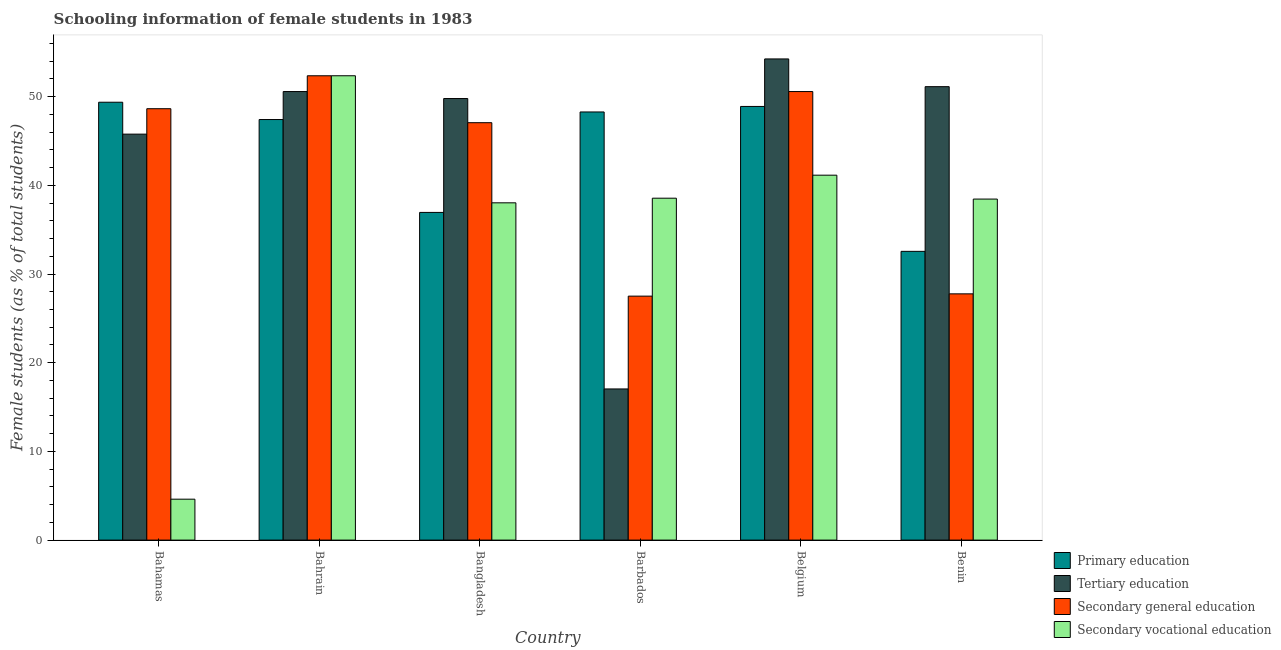How many different coloured bars are there?
Give a very brief answer. 4. Are the number of bars on each tick of the X-axis equal?
Ensure brevity in your answer.  Yes. What is the label of the 6th group of bars from the left?
Keep it short and to the point. Benin. What is the percentage of female students in secondary vocational education in Bahrain?
Offer a terse response. 52.36. Across all countries, what is the maximum percentage of female students in secondary education?
Offer a very short reply. 52.36. Across all countries, what is the minimum percentage of female students in secondary education?
Your response must be concise. 27.51. In which country was the percentage of female students in primary education maximum?
Offer a very short reply. Bahamas. In which country was the percentage of female students in tertiary education minimum?
Your response must be concise. Barbados. What is the total percentage of female students in tertiary education in the graph?
Provide a short and direct response. 268.57. What is the difference between the percentage of female students in primary education in Bahrain and that in Benin?
Give a very brief answer. 14.86. What is the difference between the percentage of female students in secondary education in Bahrain and the percentage of female students in secondary vocational education in Belgium?
Keep it short and to the point. 11.21. What is the average percentage of female students in primary education per country?
Give a very brief answer. 43.91. What is the difference between the percentage of female students in primary education and percentage of female students in secondary vocational education in Benin?
Your answer should be compact. -5.89. In how many countries, is the percentage of female students in secondary education greater than 4 %?
Provide a short and direct response. 6. What is the ratio of the percentage of female students in secondary education in Bahrain to that in Barbados?
Offer a terse response. 1.9. What is the difference between the highest and the second highest percentage of female students in tertiary education?
Give a very brief answer. 3.13. What is the difference between the highest and the lowest percentage of female students in secondary vocational education?
Give a very brief answer. 47.74. What does the 2nd bar from the left in Bahamas represents?
Give a very brief answer. Tertiary education. What does the 3rd bar from the right in Barbados represents?
Your answer should be compact. Tertiary education. How many countries are there in the graph?
Your answer should be compact. 6. Are the values on the major ticks of Y-axis written in scientific E-notation?
Your answer should be very brief. No. Does the graph contain any zero values?
Your answer should be compact. No. Does the graph contain grids?
Ensure brevity in your answer.  No. How are the legend labels stacked?
Your answer should be compact. Vertical. What is the title of the graph?
Offer a terse response. Schooling information of female students in 1983. What is the label or title of the X-axis?
Your answer should be very brief. Country. What is the label or title of the Y-axis?
Your answer should be very brief. Female students (as % of total students). What is the Female students (as % of total students) of Primary education in Bahamas?
Your answer should be very brief. 49.37. What is the Female students (as % of total students) of Tertiary education in Bahamas?
Offer a terse response. 45.78. What is the Female students (as % of total students) of Secondary general education in Bahamas?
Offer a very short reply. 48.64. What is the Female students (as % of total students) of Secondary vocational education in Bahamas?
Keep it short and to the point. 4.61. What is the Female students (as % of total students) of Primary education in Bahrain?
Ensure brevity in your answer.  47.42. What is the Female students (as % of total students) in Tertiary education in Bahrain?
Keep it short and to the point. 50.58. What is the Female students (as % of total students) of Secondary general education in Bahrain?
Your answer should be compact. 52.36. What is the Female students (as % of total students) of Secondary vocational education in Bahrain?
Ensure brevity in your answer.  52.36. What is the Female students (as % of total students) in Primary education in Bangladesh?
Make the answer very short. 36.95. What is the Female students (as % of total students) in Tertiary education in Bangladesh?
Your response must be concise. 49.79. What is the Female students (as % of total students) of Secondary general education in Bangladesh?
Give a very brief answer. 47.06. What is the Female students (as % of total students) in Secondary vocational education in Bangladesh?
Make the answer very short. 38.03. What is the Female students (as % of total students) of Primary education in Barbados?
Provide a short and direct response. 48.27. What is the Female students (as % of total students) in Tertiary education in Barbados?
Provide a succinct answer. 17.04. What is the Female students (as % of total students) of Secondary general education in Barbados?
Make the answer very short. 27.51. What is the Female students (as % of total students) of Secondary vocational education in Barbados?
Your answer should be compact. 38.55. What is the Female students (as % of total students) in Primary education in Belgium?
Ensure brevity in your answer.  48.9. What is the Female students (as % of total students) in Tertiary education in Belgium?
Make the answer very short. 54.25. What is the Female students (as % of total students) of Secondary general education in Belgium?
Give a very brief answer. 50.58. What is the Female students (as % of total students) in Secondary vocational education in Belgium?
Your response must be concise. 41.15. What is the Female students (as % of total students) of Primary education in Benin?
Your response must be concise. 32.56. What is the Female students (as % of total students) of Tertiary education in Benin?
Your response must be concise. 51.13. What is the Female students (as % of total students) in Secondary general education in Benin?
Your answer should be very brief. 27.77. What is the Female students (as % of total students) in Secondary vocational education in Benin?
Your answer should be very brief. 38.45. Across all countries, what is the maximum Female students (as % of total students) in Primary education?
Keep it short and to the point. 49.37. Across all countries, what is the maximum Female students (as % of total students) of Tertiary education?
Ensure brevity in your answer.  54.25. Across all countries, what is the maximum Female students (as % of total students) of Secondary general education?
Make the answer very short. 52.36. Across all countries, what is the maximum Female students (as % of total students) of Secondary vocational education?
Your answer should be very brief. 52.36. Across all countries, what is the minimum Female students (as % of total students) of Primary education?
Offer a terse response. 32.56. Across all countries, what is the minimum Female students (as % of total students) in Tertiary education?
Provide a succinct answer. 17.04. Across all countries, what is the minimum Female students (as % of total students) of Secondary general education?
Give a very brief answer. 27.51. Across all countries, what is the minimum Female students (as % of total students) in Secondary vocational education?
Ensure brevity in your answer.  4.61. What is the total Female students (as % of total students) of Primary education in the graph?
Your answer should be compact. 263.47. What is the total Female students (as % of total students) of Tertiary education in the graph?
Make the answer very short. 268.57. What is the total Female students (as % of total students) in Secondary general education in the graph?
Give a very brief answer. 253.91. What is the total Female students (as % of total students) of Secondary vocational education in the graph?
Keep it short and to the point. 213.15. What is the difference between the Female students (as % of total students) of Primary education in Bahamas and that in Bahrain?
Your response must be concise. 1.95. What is the difference between the Female students (as % of total students) of Tertiary education in Bahamas and that in Bahrain?
Make the answer very short. -4.8. What is the difference between the Female students (as % of total students) in Secondary general education in Bahamas and that in Bahrain?
Ensure brevity in your answer.  -3.71. What is the difference between the Female students (as % of total students) in Secondary vocational education in Bahamas and that in Bahrain?
Ensure brevity in your answer.  -47.74. What is the difference between the Female students (as % of total students) of Primary education in Bahamas and that in Bangladesh?
Your answer should be compact. 12.42. What is the difference between the Female students (as % of total students) of Tertiary education in Bahamas and that in Bangladesh?
Ensure brevity in your answer.  -4.01. What is the difference between the Female students (as % of total students) of Secondary general education in Bahamas and that in Bangladesh?
Keep it short and to the point. 1.58. What is the difference between the Female students (as % of total students) in Secondary vocational education in Bahamas and that in Bangladesh?
Offer a terse response. -33.42. What is the difference between the Female students (as % of total students) in Primary education in Bahamas and that in Barbados?
Give a very brief answer. 1.1. What is the difference between the Female students (as % of total students) in Tertiary education in Bahamas and that in Barbados?
Ensure brevity in your answer.  28.73. What is the difference between the Female students (as % of total students) of Secondary general education in Bahamas and that in Barbados?
Your response must be concise. 21.13. What is the difference between the Female students (as % of total students) of Secondary vocational education in Bahamas and that in Barbados?
Provide a short and direct response. -33.94. What is the difference between the Female students (as % of total students) of Primary education in Bahamas and that in Belgium?
Offer a terse response. 0.47. What is the difference between the Female students (as % of total students) in Tertiary education in Bahamas and that in Belgium?
Provide a succinct answer. -8.48. What is the difference between the Female students (as % of total students) in Secondary general education in Bahamas and that in Belgium?
Give a very brief answer. -1.93. What is the difference between the Female students (as % of total students) of Secondary vocational education in Bahamas and that in Belgium?
Ensure brevity in your answer.  -36.53. What is the difference between the Female students (as % of total students) in Primary education in Bahamas and that in Benin?
Your answer should be very brief. 16.82. What is the difference between the Female students (as % of total students) in Tertiary education in Bahamas and that in Benin?
Ensure brevity in your answer.  -5.35. What is the difference between the Female students (as % of total students) in Secondary general education in Bahamas and that in Benin?
Give a very brief answer. 20.88. What is the difference between the Female students (as % of total students) in Secondary vocational education in Bahamas and that in Benin?
Your answer should be compact. -33.84. What is the difference between the Female students (as % of total students) in Primary education in Bahrain and that in Bangladesh?
Your response must be concise. 10.47. What is the difference between the Female students (as % of total students) of Tertiary education in Bahrain and that in Bangladesh?
Your response must be concise. 0.79. What is the difference between the Female students (as % of total students) in Secondary general education in Bahrain and that in Bangladesh?
Provide a succinct answer. 5.29. What is the difference between the Female students (as % of total students) in Secondary vocational education in Bahrain and that in Bangladesh?
Your answer should be very brief. 14.33. What is the difference between the Female students (as % of total students) of Primary education in Bahrain and that in Barbados?
Keep it short and to the point. -0.85. What is the difference between the Female students (as % of total students) of Tertiary education in Bahrain and that in Barbados?
Ensure brevity in your answer.  33.53. What is the difference between the Female students (as % of total students) in Secondary general education in Bahrain and that in Barbados?
Offer a terse response. 24.85. What is the difference between the Female students (as % of total students) of Secondary vocational education in Bahrain and that in Barbados?
Offer a terse response. 13.81. What is the difference between the Female students (as % of total students) in Primary education in Bahrain and that in Belgium?
Your answer should be very brief. -1.48. What is the difference between the Female students (as % of total students) of Tertiary education in Bahrain and that in Belgium?
Provide a short and direct response. -3.68. What is the difference between the Female students (as % of total students) in Secondary general education in Bahrain and that in Belgium?
Ensure brevity in your answer.  1.78. What is the difference between the Female students (as % of total students) in Secondary vocational education in Bahrain and that in Belgium?
Offer a terse response. 11.21. What is the difference between the Female students (as % of total students) of Primary education in Bahrain and that in Benin?
Offer a terse response. 14.86. What is the difference between the Female students (as % of total students) in Tertiary education in Bahrain and that in Benin?
Ensure brevity in your answer.  -0.55. What is the difference between the Female students (as % of total students) of Secondary general education in Bahrain and that in Benin?
Ensure brevity in your answer.  24.59. What is the difference between the Female students (as % of total students) of Secondary vocational education in Bahrain and that in Benin?
Give a very brief answer. 13.9. What is the difference between the Female students (as % of total students) in Primary education in Bangladesh and that in Barbados?
Offer a very short reply. -11.33. What is the difference between the Female students (as % of total students) in Tertiary education in Bangladesh and that in Barbados?
Make the answer very short. 32.74. What is the difference between the Female students (as % of total students) of Secondary general education in Bangladesh and that in Barbados?
Keep it short and to the point. 19.56. What is the difference between the Female students (as % of total students) of Secondary vocational education in Bangladesh and that in Barbados?
Make the answer very short. -0.52. What is the difference between the Female students (as % of total students) in Primary education in Bangladesh and that in Belgium?
Your answer should be compact. -11.95. What is the difference between the Female students (as % of total students) of Tertiary education in Bangladesh and that in Belgium?
Ensure brevity in your answer.  -4.47. What is the difference between the Female students (as % of total students) of Secondary general education in Bangladesh and that in Belgium?
Your answer should be very brief. -3.51. What is the difference between the Female students (as % of total students) of Secondary vocational education in Bangladesh and that in Belgium?
Give a very brief answer. -3.12. What is the difference between the Female students (as % of total students) in Primary education in Bangladesh and that in Benin?
Your answer should be very brief. 4.39. What is the difference between the Female students (as % of total students) of Tertiary education in Bangladesh and that in Benin?
Make the answer very short. -1.34. What is the difference between the Female students (as % of total students) of Secondary general education in Bangladesh and that in Benin?
Give a very brief answer. 19.3. What is the difference between the Female students (as % of total students) in Secondary vocational education in Bangladesh and that in Benin?
Ensure brevity in your answer.  -0.42. What is the difference between the Female students (as % of total students) of Primary education in Barbados and that in Belgium?
Ensure brevity in your answer.  -0.62. What is the difference between the Female students (as % of total students) in Tertiary education in Barbados and that in Belgium?
Your response must be concise. -37.21. What is the difference between the Female students (as % of total students) of Secondary general education in Barbados and that in Belgium?
Make the answer very short. -23.07. What is the difference between the Female students (as % of total students) of Secondary vocational education in Barbados and that in Belgium?
Your answer should be very brief. -2.6. What is the difference between the Female students (as % of total students) in Primary education in Barbados and that in Benin?
Your answer should be compact. 15.72. What is the difference between the Female students (as % of total students) in Tertiary education in Barbados and that in Benin?
Make the answer very short. -34.08. What is the difference between the Female students (as % of total students) in Secondary general education in Barbados and that in Benin?
Ensure brevity in your answer.  -0.26. What is the difference between the Female students (as % of total students) in Secondary vocational education in Barbados and that in Benin?
Keep it short and to the point. 0.1. What is the difference between the Female students (as % of total students) in Primary education in Belgium and that in Benin?
Your response must be concise. 16.34. What is the difference between the Female students (as % of total students) of Tertiary education in Belgium and that in Benin?
Ensure brevity in your answer.  3.13. What is the difference between the Female students (as % of total students) of Secondary general education in Belgium and that in Benin?
Keep it short and to the point. 22.81. What is the difference between the Female students (as % of total students) in Secondary vocational education in Belgium and that in Benin?
Give a very brief answer. 2.69. What is the difference between the Female students (as % of total students) in Primary education in Bahamas and the Female students (as % of total students) in Tertiary education in Bahrain?
Make the answer very short. -1.2. What is the difference between the Female students (as % of total students) in Primary education in Bahamas and the Female students (as % of total students) in Secondary general education in Bahrain?
Your response must be concise. -2.98. What is the difference between the Female students (as % of total students) of Primary education in Bahamas and the Female students (as % of total students) of Secondary vocational education in Bahrain?
Your answer should be compact. -2.98. What is the difference between the Female students (as % of total students) of Tertiary education in Bahamas and the Female students (as % of total students) of Secondary general education in Bahrain?
Ensure brevity in your answer.  -6.58. What is the difference between the Female students (as % of total students) in Tertiary education in Bahamas and the Female students (as % of total students) in Secondary vocational education in Bahrain?
Your answer should be compact. -6.58. What is the difference between the Female students (as % of total students) of Secondary general education in Bahamas and the Female students (as % of total students) of Secondary vocational education in Bahrain?
Give a very brief answer. -3.71. What is the difference between the Female students (as % of total students) in Primary education in Bahamas and the Female students (as % of total students) in Tertiary education in Bangladesh?
Ensure brevity in your answer.  -0.42. What is the difference between the Female students (as % of total students) of Primary education in Bahamas and the Female students (as % of total students) of Secondary general education in Bangladesh?
Provide a succinct answer. 2.31. What is the difference between the Female students (as % of total students) of Primary education in Bahamas and the Female students (as % of total students) of Secondary vocational education in Bangladesh?
Provide a succinct answer. 11.34. What is the difference between the Female students (as % of total students) of Tertiary education in Bahamas and the Female students (as % of total students) of Secondary general education in Bangladesh?
Give a very brief answer. -1.29. What is the difference between the Female students (as % of total students) of Tertiary education in Bahamas and the Female students (as % of total students) of Secondary vocational education in Bangladesh?
Your response must be concise. 7.75. What is the difference between the Female students (as % of total students) of Secondary general education in Bahamas and the Female students (as % of total students) of Secondary vocational education in Bangladesh?
Make the answer very short. 10.61. What is the difference between the Female students (as % of total students) in Primary education in Bahamas and the Female students (as % of total students) in Tertiary education in Barbados?
Provide a short and direct response. 32.33. What is the difference between the Female students (as % of total students) of Primary education in Bahamas and the Female students (as % of total students) of Secondary general education in Barbados?
Your response must be concise. 21.86. What is the difference between the Female students (as % of total students) in Primary education in Bahamas and the Female students (as % of total students) in Secondary vocational education in Barbados?
Give a very brief answer. 10.82. What is the difference between the Female students (as % of total students) in Tertiary education in Bahamas and the Female students (as % of total students) in Secondary general education in Barbados?
Your response must be concise. 18.27. What is the difference between the Female students (as % of total students) of Tertiary education in Bahamas and the Female students (as % of total students) of Secondary vocational education in Barbados?
Keep it short and to the point. 7.22. What is the difference between the Female students (as % of total students) of Secondary general education in Bahamas and the Female students (as % of total students) of Secondary vocational education in Barbados?
Your answer should be compact. 10.09. What is the difference between the Female students (as % of total students) in Primary education in Bahamas and the Female students (as % of total students) in Tertiary education in Belgium?
Your answer should be compact. -4.88. What is the difference between the Female students (as % of total students) of Primary education in Bahamas and the Female students (as % of total students) of Secondary general education in Belgium?
Keep it short and to the point. -1.2. What is the difference between the Female students (as % of total students) of Primary education in Bahamas and the Female students (as % of total students) of Secondary vocational education in Belgium?
Your answer should be compact. 8.23. What is the difference between the Female students (as % of total students) of Tertiary education in Bahamas and the Female students (as % of total students) of Secondary general education in Belgium?
Offer a terse response. -4.8. What is the difference between the Female students (as % of total students) of Tertiary education in Bahamas and the Female students (as % of total students) of Secondary vocational education in Belgium?
Your response must be concise. 4.63. What is the difference between the Female students (as % of total students) in Secondary general education in Bahamas and the Female students (as % of total students) in Secondary vocational education in Belgium?
Make the answer very short. 7.49. What is the difference between the Female students (as % of total students) of Primary education in Bahamas and the Female students (as % of total students) of Tertiary education in Benin?
Keep it short and to the point. -1.76. What is the difference between the Female students (as % of total students) in Primary education in Bahamas and the Female students (as % of total students) in Secondary general education in Benin?
Your response must be concise. 21.61. What is the difference between the Female students (as % of total students) in Primary education in Bahamas and the Female students (as % of total students) in Secondary vocational education in Benin?
Your answer should be compact. 10.92. What is the difference between the Female students (as % of total students) of Tertiary education in Bahamas and the Female students (as % of total students) of Secondary general education in Benin?
Provide a succinct answer. 18.01. What is the difference between the Female students (as % of total students) of Tertiary education in Bahamas and the Female students (as % of total students) of Secondary vocational education in Benin?
Your response must be concise. 7.32. What is the difference between the Female students (as % of total students) in Secondary general education in Bahamas and the Female students (as % of total students) in Secondary vocational education in Benin?
Provide a succinct answer. 10.19. What is the difference between the Female students (as % of total students) of Primary education in Bahrain and the Female students (as % of total students) of Tertiary education in Bangladesh?
Provide a short and direct response. -2.37. What is the difference between the Female students (as % of total students) in Primary education in Bahrain and the Female students (as % of total students) in Secondary general education in Bangladesh?
Provide a succinct answer. 0.36. What is the difference between the Female students (as % of total students) of Primary education in Bahrain and the Female students (as % of total students) of Secondary vocational education in Bangladesh?
Ensure brevity in your answer.  9.39. What is the difference between the Female students (as % of total students) in Tertiary education in Bahrain and the Female students (as % of total students) in Secondary general education in Bangladesh?
Ensure brevity in your answer.  3.51. What is the difference between the Female students (as % of total students) in Tertiary education in Bahrain and the Female students (as % of total students) in Secondary vocational education in Bangladesh?
Make the answer very short. 12.55. What is the difference between the Female students (as % of total students) in Secondary general education in Bahrain and the Female students (as % of total students) in Secondary vocational education in Bangladesh?
Give a very brief answer. 14.33. What is the difference between the Female students (as % of total students) in Primary education in Bahrain and the Female students (as % of total students) in Tertiary education in Barbados?
Make the answer very short. 30.38. What is the difference between the Female students (as % of total students) in Primary education in Bahrain and the Female students (as % of total students) in Secondary general education in Barbados?
Give a very brief answer. 19.91. What is the difference between the Female students (as % of total students) in Primary education in Bahrain and the Female students (as % of total students) in Secondary vocational education in Barbados?
Ensure brevity in your answer.  8.87. What is the difference between the Female students (as % of total students) in Tertiary education in Bahrain and the Female students (as % of total students) in Secondary general education in Barbados?
Give a very brief answer. 23.07. What is the difference between the Female students (as % of total students) of Tertiary education in Bahrain and the Female students (as % of total students) of Secondary vocational education in Barbados?
Give a very brief answer. 12.02. What is the difference between the Female students (as % of total students) in Secondary general education in Bahrain and the Female students (as % of total students) in Secondary vocational education in Barbados?
Provide a succinct answer. 13.81. What is the difference between the Female students (as % of total students) in Primary education in Bahrain and the Female students (as % of total students) in Tertiary education in Belgium?
Make the answer very short. -6.83. What is the difference between the Female students (as % of total students) in Primary education in Bahrain and the Female students (as % of total students) in Secondary general education in Belgium?
Make the answer very short. -3.15. What is the difference between the Female students (as % of total students) in Primary education in Bahrain and the Female students (as % of total students) in Secondary vocational education in Belgium?
Give a very brief answer. 6.27. What is the difference between the Female students (as % of total students) of Tertiary education in Bahrain and the Female students (as % of total students) of Secondary general education in Belgium?
Offer a very short reply. 0. What is the difference between the Female students (as % of total students) of Tertiary education in Bahrain and the Female students (as % of total students) of Secondary vocational education in Belgium?
Provide a short and direct response. 9.43. What is the difference between the Female students (as % of total students) in Secondary general education in Bahrain and the Female students (as % of total students) in Secondary vocational education in Belgium?
Ensure brevity in your answer.  11.21. What is the difference between the Female students (as % of total students) of Primary education in Bahrain and the Female students (as % of total students) of Tertiary education in Benin?
Your answer should be very brief. -3.71. What is the difference between the Female students (as % of total students) in Primary education in Bahrain and the Female students (as % of total students) in Secondary general education in Benin?
Provide a short and direct response. 19.65. What is the difference between the Female students (as % of total students) in Primary education in Bahrain and the Female students (as % of total students) in Secondary vocational education in Benin?
Give a very brief answer. 8.97. What is the difference between the Female students (as % of total students) of Tertiary education in Bahrain and the Female students (as % of total students) of Secondary general education in Benin?
Give a very brief answer. 22.81. What is the difference between the Female students (as % of total students) in Tertiary education in Bahrain and the Female students (as % of total students) in Secondary vocational education in Benin?
Keep it short and to the point. 12.12. What is the difference between the Female students (as % of total students) in Secondary general education in Bahrain and the Female students (as % of total students) in Secondary vocational education in Benin?
Offer a very short reply. 13.9. What is the difference between the Female students (as % of total students) of Primary education in Bangladesh and the Female students (as % of total students) of Tertiary education in Barbados?
Offer a terse response. 19.9. What is the difference between the Female students (as % of total students) of Primary education in Bangladesh and the Female students (as % of total students) of Secondary general education in Barbados?
Offer a very short reply. 9.44. What is the difference between the Female students (as % of total students) of Primary education in Bangladesh and the Female students (as % of total students) of Secondary vocational education in Barbados?
Your answer should be compact. -1.6. What is the difference between the Female students (as % of total students) of Tertiary education in Bangladesh and the Female students (as % of total students) of Secondary general education in Barbados?
Offer a terse response. 22.28. What is the difference between the Female students (as % of total students) in Tertiary education in Bangladesh and the Female students (as % of total students) in Secondary vocational education in Barbados?
Your answer should be very brief. 11.24. What is the difference between the Female students (as % of total students) in Secondary general education in Bangladesh and the Female students (as % of total students) in Secondary vocational education in Barbados?
Provide a short and direct response. 8.51. What is the difference between the Female students (as % of total students) in Primary education in Bangladesh and the Female students (as % of total students) in Tertiary education in Belgium?
Ensure brevity in your answer.  -17.31. What is the difference between the Female students (as % of total students) in Primary education in Bangladesh and the Female students (as % of total students) in Secondary general education in Belgium?
Provide a short and direct response. -13.63. What is the difference between the Female students (as % of total students) of Primary education in Bangladesh and the Female students (as % of total students) of Secondary vocational education in Belgium?
Your answer should be very brief. -4.2. What is the difference between the Female students (as % of total students) of Tertiary education in Bangladesh and the Female students (as % of total students) of Secondary general education in Belgium?
Your answer should be very brief. -0.79. What is the difference between the Female students (as % of total students) in Tertiary education in Bangladesh and the Female students (as % of total students) in Secondary vocational education in Belgium?
Provide a short and direct response. 8.64. What is the difference between the Female students (as % of total students) in Secondary general education in Bangladesh and the Female students (as % of total students) in Secondary vocational education in Belgium?
Provide a short and direct response. 5.92. What is the difference between the Female students (as % of total students) in Primary education in Bangladesh and the Female students (as % of total students) in Tertiary education in Benin?
Your response must be concise. -14.18. What is the difference between the Female students (as % of total students) of Primary education in Bangladesh and the Female students (as % of total students) of Secondary general education in Benin?
Provide a succinct answer. 9.18. What is the difference between the Female students (as % of total students) in Primary education in Bangladesh and the Female students (as % of total students) in Secondary vocational education in Benin?
Make the answer very short. -1.5. What is the difference between the Female students (as % of total students) in Tertiary education in Bangladesh and the Female students (as % of total students) in Secondary general education in Benin?
Make the answer very short. 22.02. What is the difference between the Female students (as % of total students) in Tertiary education in Bangladesh and the Female students (as % of total students) in Secondary vocational education in Benin?
Your response must be concise. 11.34. What is the difference between the Female students (as % of total students) in Secondary general education in Bangladesh and the Female students (as % of total students) in Secondary vocational education in Benin?
Offer a terse response. 8.61. What is the difference between the Female students (as % of total students) in Primary education in Barbados and the Female students (as % of total students) in Tertiary education in Belgium?
Your response must be concise. -5.98. What is the difference between the Female students (as % of total students) in Primary education in Barbados and the Female students (as % of total students) in Secondary general education in Belgium?
Your answer should be compact. -2.3. What is the difference between the Female students (as % of total students) in Primary education in Barbados and the Female students (as % of total students) in Secondary vocational education in Belgium?
Your answer should be compact. 7.13. What is the difference between the Female students (as % of total students) of Tertiary education in Barbados and the Female students (as % of total students) of Secondary general education in Belgium?
Keep it short and to the point. -33.53. What is the difference between the Female students (as % of total students) in Tertiary education in Barbados and the Female students (as % of total students) in Secondary vocational education in Belgium?
Offer a terse response. -24.1. What is the difference between the Female students (as % of total students) in Secondary general education in Barbados and the Female students (as % of total students) in Secondary vocational education in Belgium?
Offer a terse response. -13.64. What is the difference between the Female students (as % of total students) in Primary education in Barbados and the Female students (as % of total students) in Tertiary education in Benin?
Offer a terse response. -2.85. What is the difference between the Female students (as % of total students) in Primary education in Barbados and the Female students (as % of total students) in Secondary general education in Benin?
Provide a succinct answer. 20.51. What is the difference between the Female students (as % of total students) of Primary education in Barbados and the Female students (as % of total students) of Secondary vocational education in Benin?
Your response must be concise. 9.82. What is the difference between the Female students (as % of total students) of Tertiary education in Barbados and the Female students (as % of total students) of Secondary general education in Benin?
Your answer should be compact. -10.72. What is the difference between the Female students (as % of total students) in Tertiary education in Barbados and the Female students (as % of total students) in Secondary vocational education in Benin?
Your response must be concise. -21.41. What is the difference between the Female students (as % of total students) of Secondary general education in Barbados and the Female students (as % of total students) of Secondary vocational education in Benin?
Provide a short and direct response. -10.94. What is the difference between the Female students (as % of total students) in Primary education in Belgium and the Female students (as % of total students) in Tertiary education in Benin?
Your response must be concise. -2.23. What is the difference between the Female students (as % of total students) in Primary education in Belgium and the Female students (as % of total students) in Secondary general education in Benin?
Your answer should be very brief. 21.13. What is the difference between the Female students (as % of total students) in Primary education in Belgium and the Female students (as % of total students) in Secondary vocational education in Benin?
Your answer should be compact. 10.45. What is the difference between the Female students (as % of total students) of Tertiary education in Belgium and the Female students (as % of total students) of Secondary general education in Benin?
Offer a terse response. 26.49. What is the difference between the Female students (as % of total students) of Tertiary education in Belgium and the Female students (as % of total students) of Secondary vocational education in Benin?
Your response must be concise. 15.8. What is the difference between the Female students (as % of total students) in Secondary general education in Belgium and the Female students (as % of total students) in Secondary vocational education in Benin?
Provide a succinct answer. 12.12. What is the average Female students (as % of total students) in Primary education per country?
Keep it short and to the point. 43.91. What is the average Female students (as % of total students) of Tertiary education per country?
Your response must be concise. 44.76. What is the average Female students (as % of total students) in Secondary general education per country?
Your answer should be very brief. 42.32. What is the average Female students (as % of total students) of Secondary vocational education per country?
Give a very brief answer. 35.53. What is the difference between the Female students (as % of total students) in Primary education and Female students (as % of total students) in Tertiary education in Bahamas?
Offer a very short reply. 3.6. What is the difference between the Female students (as % of total students) of Primary education and Female students (as % of total students) of Secondary general education in Bahamas?
Make the answer very short. 0.73. What is the difference between the Female students (as % of total students) of Primary education and Female students (as % of total students) of Secondary vocational education in Bahamas?
Make the answer very short. 44.76. What is the difference between the Female students (as % of total students) of Tertiary education and Female students (as % of total students) of Secondary general education in Bahamas?
Your response must be concise. -2.87. What is the difference between the Female students (as % of total students) in Tertiary education and Female students (as % of total students) in Secondary vocational education in Bahamas?
Give a very brief answer. 41.16. What is the difference between the Female students (as % of total students) of Secondary general education and Female students (as % of total students) of Secondary vocational education in Bahamas?
Provide a short and direct response. 44.03. What is the difference between the Female students (as % of total students) in Primary education and Female students (as % of total students) in Tertiary education in Bahrain?
Give a very brief answer. -3.15. What is the difference between the Female students (as % of total students) of Primary education and Female students (as % of total students) of Secondary general education in Bahrain?
Your answer should be compact. -4.94. What is the difference between the Female students (as % of total students) of Primary education and Female students (as % of total students) of Secondary vocational education in Bahrain?
Make the answer very short. -4.94. What is the difference between the Female students (as % of total students) in Tertiary education and Female students (as % of total students) in Secondary general education in Bahrain?
Provide a short and direct response. -1.78. What is the difference between the Female students (as % of total students) in Tertiary education and Female students (as % of total students) in Secondary vocational education in Bahrain?
Your response must be concise. -1.78. What is the difference between the Female students (as % of total students) of Secondary general education and Female students (as % of total students) of Secondary vocational education in Bahrain?
Your answer should be compact. -0. What is the difference between the Female students (as % of total students) in Primary education and Female students (as % of total students) in Tertiary education in Bangladesh?
Keep it short and to the point. -12.84. What is the difference between the Female students (as % of total students) of Primary education and Female students (as % of total students) of Secondary general education in Bangladesh?
Keep it short and to the point. -10.12. What is the difference between the Female students (as % of total students) of Primary education and Female students (as % of total students) of Secondary vocational education in Bangladesh?
Your answer should be very brief. -1.08. What is the difference between the Female students (as % of total students) in Tertiary education and Female students (as % of total students) in Secondary general education in Bangladesh?
Keep it short and to the point. 2.72. What is the difference between the Female students (as % of total students) in Tertiary education and Female students (as % of total students) in Secondary vocational education in Bangladesh?
Provide a succinct answer. 11.76. What is the difference between the Female students (as % of total students) of Secondary general education and Female students (as % of total students) of Secondary vocational education in Bangladesh?
Your response must be concise. 9.04. What is the difference between the Female students (as % of total students) of Primary education and Female students (as % of total students) of Tertiary education in Barbados?
Provide a short and direct response. 31.23. What is the difference between the Female students (as % of total students) of Primary education and Female students (as % of total students) of Secondary general education in Barbados?
Keep it short and to the point. 20.77. What is the difference between the Female students (as % of total students) in Primary education and Female students (as % of total students) in Secondary vocational education in Barbados?
Provide a short and direct response. 9.72. What is the difference between the Female students (as % of total students) in Tertiary education and Female students (as % of total students) in Secondary general education in Barbados?
Your response must be concise. -10.46. What is the difference between the Female students (as % of total students) of Tertiary education and Female students (as % of total students) of Secondary vocational education in Barbados?
Your answer should be very brief. -21.51. What is the difference between the Female students (as % of total students) in Secondary general education and Female students (as % of total students) in Secondary vocational education in Barbados?
Your response must be concise. -11.04. What is the difference between the Female students (as % of total students) in Primary education and Female students (as % of total students) in Tertiary education in Belgium?
Keep it short and to the point. -5.36. What is the difference between the Female students (as % of total students) of Primary education and Female students (as % of total students) of Secondary general education in Belgium?
Your response must be concise. -1.68. What is the difference between the Female students (as % of total students) of Primary education and Female students (as % of total students) of Secondary vocational education in Belgium?
Ensure brevity in your answer.  7.75. What is the difference between the Female students (as % of total students) of Tertiary education and Female students (as % of total students) of Secondary general education in Belgium?
Provide a succinct answer. 3.68. What is the difference between the Female students (as % of total students) in Tertiary education and Female students (as % of total students) in Secondary vocational education in Belgium?
Keep it short and to the point. 13.11. What is the difference between the Female students (as % of total students) in Secondary general education and Female students (as % of total students) in Secondary vocational education in Belgium?
Keep it short and to the point. 9.43. What is the difference between the Female students (as % of total students) of Primary education and Female students (as % of total students) of Tertiary education in Benin?
Make the answer very short. -18.57. What is the difference between the Female students (as % of total students) of Primary education and Female students (as % of total students) of Secondary general education in Benin?
Make the answer very short. 4.79. What is the difference between the Female students (as % of total students) in Primary education and Female students (as % of total students) in Secondary vocational education in Benin?
Make the answer very short. -5.89. What is the difference between the Female students (as % of total students) of Tertiary education and Female students (as % of total students) of Secondary general education in Benin?
Your answer should be very brief. 23.36. What is the difference between the Female students (as % of total students) of Tertiary education and Female students (as % of total students) of Secondary vocational education in Benin?
Ensure brevity in your answer.  12.68. What is the difference between the Female students (as % of total students) in Secondary general education and Female students (as % of total students) in Secondary vocational education in Benin?
Your answer should be very brief. -10.69. What is the ratio of the Female students (as % of total students) of Primary education in Bahamas to that in Bahrain?
Your response must be concise. 1.04. What is the ratio of the Female students (as % of total students) of Tertiary education in Bahamas to that in Bahrain?
Provide a succinct answer. 0.91. What is the ratio of the Female students (as % of total students) in Secondary general education in Bahamas to that in Bahrain?
Keep it short and to the point. 0.93. What is the ratio of the Female students (as % of total students) in Secondary vocational education in Bahamas to that in Bahrain?
Keep it short and to the point. 0.09. What is the ratio of the Female students (as % of total students) of Primary education in Bahamas to that in Bangladesh?
Your answer should be very brief. 1.34. What is the ratio of the Female students (as % of total students) in Tertiary education in Bahamas to that in Bangladesh?
Your response must be concise. 0.92. What is the ratio of the Female students (as % of total students) in Secondary general education in Bahamas to that in Bangladesh?
Offer a terse response. 1.03. What is the ratio of the Female students (as % of total students) in Secondary vocational education in Bahamas to that in Bangladesh?
Ensure brevity in your answer.  0.12. What is the ratio of the Female students (as % of total students) of Primary education in Bahamas to that in Barbados?
Offer a terse response. 1.02. What is the ratio of the Female students (as % of total students) of Tertiary education in Bahamas to that in Barbados?
Your answer should be very brief. 2.69. What is the ratio of the Female students (as % of total students) of Secondary general education in Bahamas to that in Barbados?
Your answer should be very brief. 1.77. What is the ratio of the Female students (as % of total students) in Secondary vocational education in Bahamas to that in Barbados?
Keep it short and to the point. 0.12. What is the ratio of the Female students (as % of total students) of Primary education in Bahamas to that in Belgium?
Offer a terse response. 1.01. What is the ratio of the Female students (as % of total students) in Tertiary education in Bahamas to that in Belgium?
Offer a terse response. 0.84. What is the ratio of the Female students (as % of total students) in Secondary general education in Bahamas to that in Belgium?
Make the answer very short. 0.96. What is the ratio of the Female students (as % of total students) in Secondary vocational education in Bahamas to that in Belgium?
Make the answer very short. 0.11. What is the ratio of the Female students (as % of total students) of Primary education in Bahamas to that in Benin?
Keep it short and to the point. 1.52. What is the ratio of the Female students (as % of total students) of Tertiary education in Bahamas to that in Benin?
Offer a very short reply. 0.9. What is the ratio of the Female students (as % of total students) of Secondary general education in Bahamas to that in Benin?
Provide a succinct answer. 1.75. What is the ratio of the Female students (as % of total students) of Secondary vocational education in Bahamas to that in Benin?
Give a very brief answer. 0.12. What is the ratio of the Female students (as % of total students) of Primary education in Bahrain to that in Bangladesh?
Make the answer very short. 1.28. What is the ratio of the Female students (as % of total students) of Tertiary education in Bahrain to that in Bangladesh?
Provide a short and direct response. 1.02. What is the ratio of the Female students (as % of total students) in Secondary general education in Bahrain to that in Bangladesh?
Give a very brief answer. 1.11. What is the ratio of the Female students (as % of total students) of Secondary vocational education in Bahrain to that in Bangladesh?
Ensure brevity in your answer.  1.38. What is the ratio of the Female students (as % of total students) of Primary education in Bahrain to that in Barbados?
Offer a very short reply. 0.98. What is the ratio of the Female students (as % of total students) in Tertiary education in Bahrain to that in Barbados?
Your response must be concise. 2.97. What is the ratio of the Female students (as % of total students) in Secondary general education in Bahrain to that in Barbados?
Your answer should be compact. 1.9. What is the ratio of the Female students (as % of total students) of Secondary vocational education in Bahrain to that in Barbados?
Ensure brevity in your answer.  1.36. What is the ratio of the Female students (as % of total students) of Primary education in Bahrain to that in Belgium?
Ensure brevity in your answer.  0.97. What is the ratio of the Female students (as % of total students) of Tertiary education in Bahrain to that in Belgium?
Your answer should be very brief. 0.93. What is the ratio of the Female students (as % of total students) in Secondary general education in Bahrain to that in Belgium?
Your answer should be very brief. 1.04. What is the ratio of the Female students (as % of total students) of Secondary vocational education in Bahrain to that in Belgium?
Ensure brevity in your answer.  1.27. What is the ratio of the Female students (as % of total students) of Primary education in Bahrain to that in Benin?
Offer a terse response. 1.46. What is the ratio of the Female students (as % of total students) in Secondary general education in Bahrain to that in Benin?
Provide a short and direct response. 1.89. What is the ratio of the Female students (as % of total students) in Secondary vocational education in Bahrain to that in Benin?
Your response must be concise. 1.36. What is the ratio of the Female students (as % of total students) of Primary education in Bangladesh to that in Barbados?
Make the answer very short. 0.77. What is the ratio of the Female students (as % of total students) in Tertiary education in Bangladesh to that in Barbados?
Ensure brevity in your answer.  2.92. What is the ratio of the Female students (as % of total students) of Secondary general education in Bangladesh to that in Barbados?
Keep it short and to the point. 1.71. What is the ratio of the Female students (as % of total students) in Secondary vocational education in Bangladesh to that in Barbados?
Your answer should be compact. 0.99. What is the ratio of the Female students (as % of total students) in Primary education in Bangladesh to that in Belgium?
Provide a short and direct response. 0.76. What is the ratio of the Female students (as % of total students) of Tertiary education in Bangladesh to that in Belgium?
Your response must be concise. 0.92. What is the ratio of the Female students (as % of total students) in Secondary general education in Bangladesh to that in Belgium?
Provide a succinct answer. 0.93. What is the ratio of the Female students (as % of total students) of Secondary vocational education in Bangladesh to that in Belgium?
Provide a short and direct response. 0.92. What is the ratio of the Female students (as % of total students) of Primary education in Bangladesh to that in Benin?
Provide a short and direct response. 1.13. What is the ratio of the Female students (as % of total students) in Tertiary education in Bangladesh to that in Benin?
Your response must be concise. 0.97. What is the ratio of the Female students (as % of total students) of Secondary general education in Bangladesh to that in Benin?
Offer a very short reply. 1.7. What is the ratio of the Female students (as % of total students) of Primary education in Barbados to that in Belgium?
Offer a very short reply. 0.99. What is the ratio of the Female students (as % of total students) in Tertiary education in Barbados to that in Belgium?
Make the answer very short. 0.31. What is the ratio of the Female students (as % of total students) of Secondary general education in Barbados to that in Belgium?
Offer a terse response. 0.54. What is the ratio of the Female students (as % of total students) of Secondary vocational education in Barbados to that in Belgium?
Your answer should be compact. 0.94. What is the ratio of the Female students (as % of total students) of Primary education in Barbados to that in Benin?
Your answer should be compact. 1.48. What is the ratio of the Female students (as % of total students) of Tertiary education in Barbados to that in Benin?
Give a very brief answer. 0.33. What is the ratio of the Female students (as % of total students) of Secondary general education in Barbados to that in Benin?
Your answer should be compact. 0.99. What is the ratio of the Female students (as % of total students) in Primary education in Belgium to that in Benin?
Offer a terse response. 1.5. What is the ratio of the Female students (as % of total students) in Tertiary education in Belgium to that in Benin?
Your response must be concise. 1.06. What is the ratio of the Female students (as % of total students) of Secondary general education in Belgium to that in Benin?
Your response must be concise. 1.82. What is the ratio of the Female students (as % of total students) of Secondary vocational education in Belgium to that in Benin?
Offer a terse response. 1.07. What is the difference between the highest and the second highest Female students (as % of total students) in Primary education?
Ensure brevity in your answer.  0.47. What is the difference between the highest and the second highest Female students (as % of total students) of Tertiary education?
Offer a terse response. 3.13. What is the difference between the highest and the second highest Female students (as % of total students) in Secondary general education?
Ensure brevity in your answer.  1.78. What is the difference between the highest and the second highest Female students (as % of total students) of Secondary vocational education?
Make the answer very short. 11.21. What is the difference between the highest and the lowest Female students (as % of total students) of Primary education?
Make the answer very short. 16.82. What is the difference between the highest and the lowest Female students (as % of total students) of Tertiary education?
Provide a succinct answer. 37.21. What is the difference between the highest and the lowest Female students (as % of total students) of Secondary general education?
Offer a terse response. 24.85. What is the difference between the highest and the lowest Female students (as % of total students) of Secondary vocational education?
Ensure brevity in your answer.  47.74. 